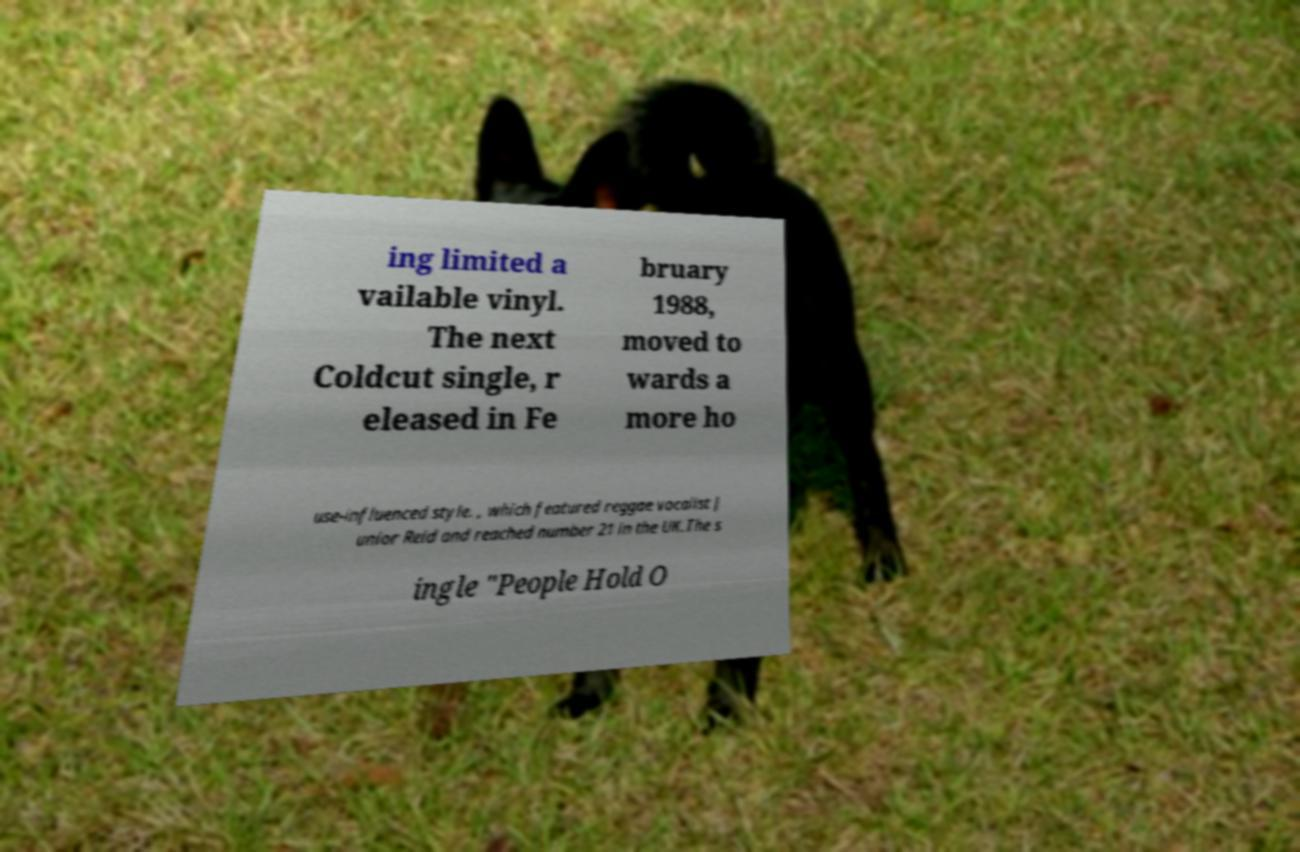Please read and relay the text visible in this image. What does it say? ing limited a vailable vinyl. The next Coldcut single, r eleased in Fe bruary 1988, moved to wards a more ho use-influenced style. , which featured reggae vocalist J unior Reid and reached number 21 in the UK.The s ingle "People Hold O 